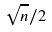Convert formula to latex. <formula><loc_0><loc_0><loc_500><loc_500>\sqrt { n } / 2</formula> 